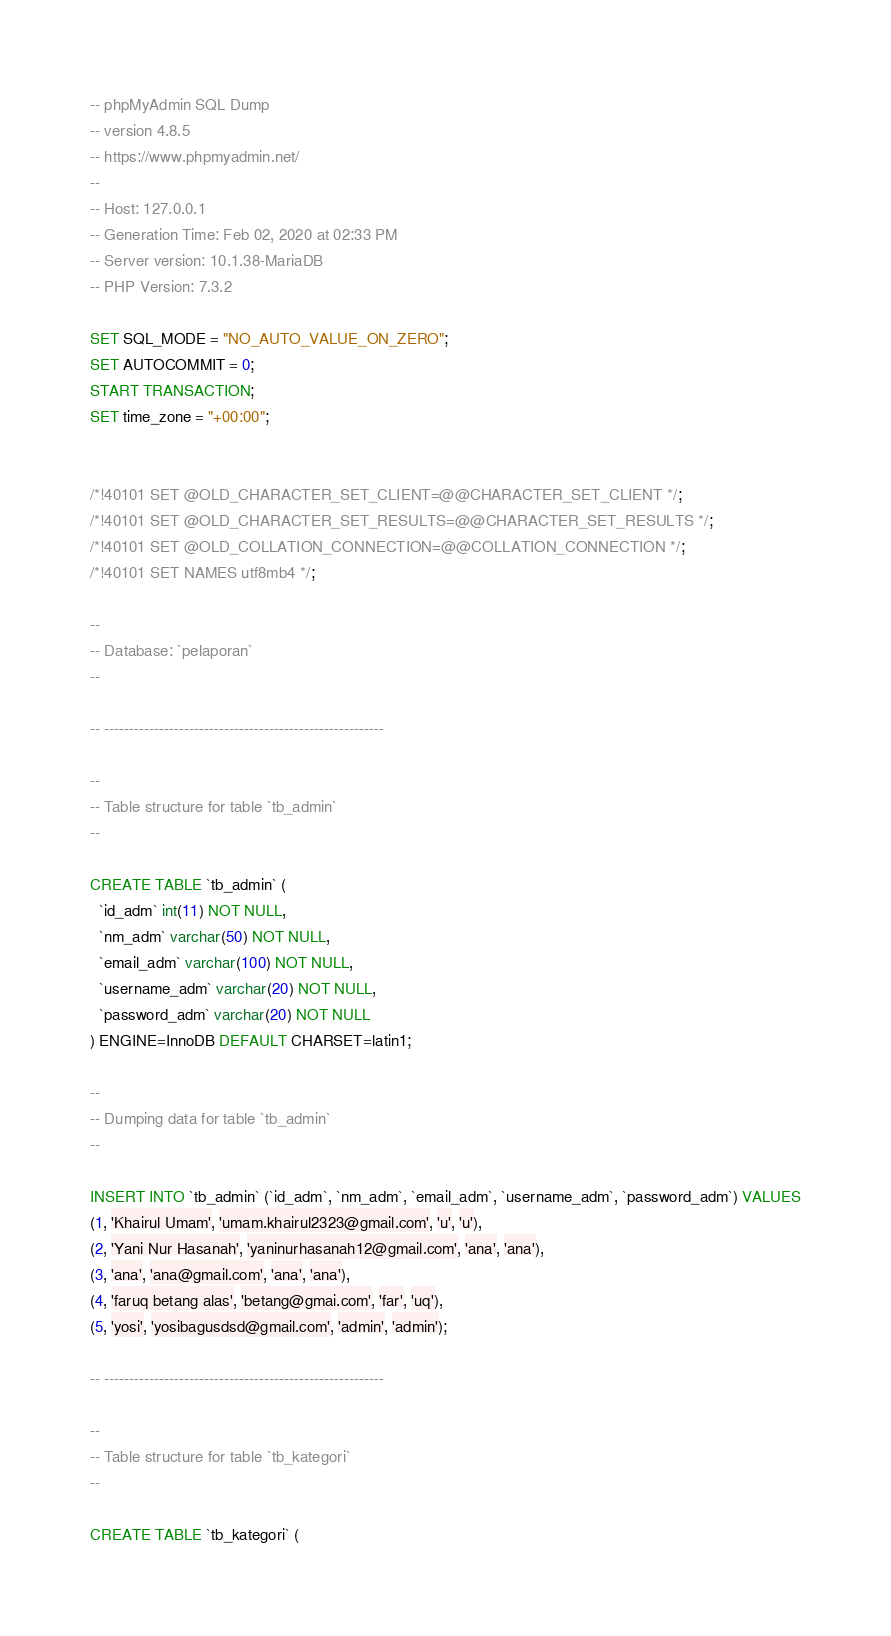<code> <loc_0><loc_0><loc_500><loc_500><_SQL_>-- phpMyAdmin SQL Dump
-- version 4.8.5
-- https://www.phpmyadmin.net/
--
-- Host: 127.0.0.1
-- Generation Time: Feb 02, 2020 at 02:33 PM
-- Server version: 10.1.38-MariaDB
-- PHP Version: 7.3.2

SET SQL_MODE = "NO_AUTO_VALUE_ON_ZERO";
SET AUTOCOMMIT = 0;
START TRANSACTION;
SET time_zone = "+00:00";


/*!40101 SET @OLD_CHARACTER_SET_CLIENT=@@CHARACTER_SET_CLIENT */;
/*!40101 SET @OLD_CHARACTER_SET_RESULTS=@@CHARACTER_SET_RESULTS */;
/*!40101 SET @OLD_COLLATION_CONNECTION=@@COLLATION_CONNECTION */;
/*!40101 SET NAMES utf8mb4 */;

--
-- Database: `pelaporan`
--

-- --------------------------------------------------------

--
-- Table structure for table `tb_admin`
--

CREATE TABLE `tb_admin` (
  `id_adm` int(11) NOT NULL,
  `nm_adm` varchar(50) NOT NULL,
  `email_adm` varchar(100) NOT NULL,
  `username_adm` varchar(20) NOT NULL,
  `password_adm` varchar(20) NOT NULL
) ENGINE=InnoDB DEFAULT CHARSET=latin1;

--
-- Dumping data for table `tb_admin`
--

INSERT INTO `tb_admin` (`id_adm`, `nm_adm`, `email_adm`, `username_adm`, `password_adm`) VALUES
(1, 'Khairul Umam', 'umam.khairul2323@gmail.com', 'u', 'u'),
(2, 'Yani Nur Hasanah', 'yaninurhasanah12@gmail.com', 'ana', 'ana'),
(3, 'ana', 'ana@gmail.com', 'ana', 'ana'),
(4, 'faruq betang alas', 'betang@gmai.com', 'far', 'uq'),
(5, 'yosi', 'yosibagusdsd@gmail.com', 'admin', 'admin');

-- --------------------------------------------------------

--
-- Table structure for table `tb_kategori`
--

CREATE TABLE `tb_kategori` (</code> 